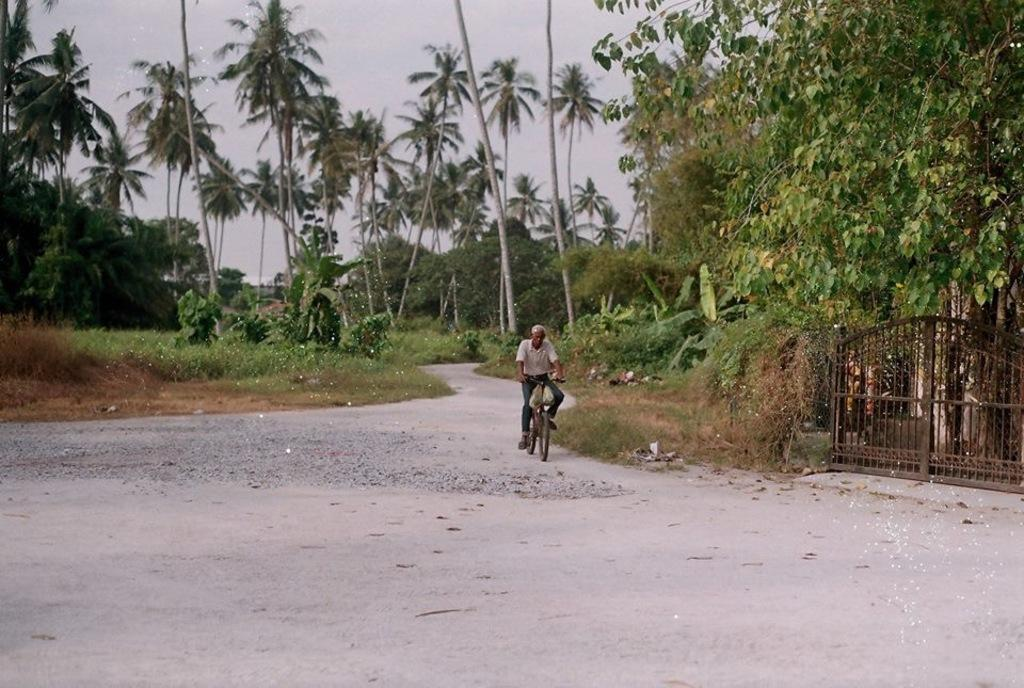What is the main subject of the image? There is a person riding a bicycle in the image. Where is the person located in the image? The person is in the center of the image. What is the setting of the image? There is a road in the image. What can be seen in the background of the image? There are trees in the background of the image. What is on the right side of the image? There is a gate on the right side of the image. What color is the crayon used to draw the bicycle in the image? There is no crayon or drawing present in the image; it is a photograph of a person riding a bicycle. How much jam is on the person's sandwich in the image? There is no sandwich or jam present in the image; it is a photograph of a person riding a bicycle. 